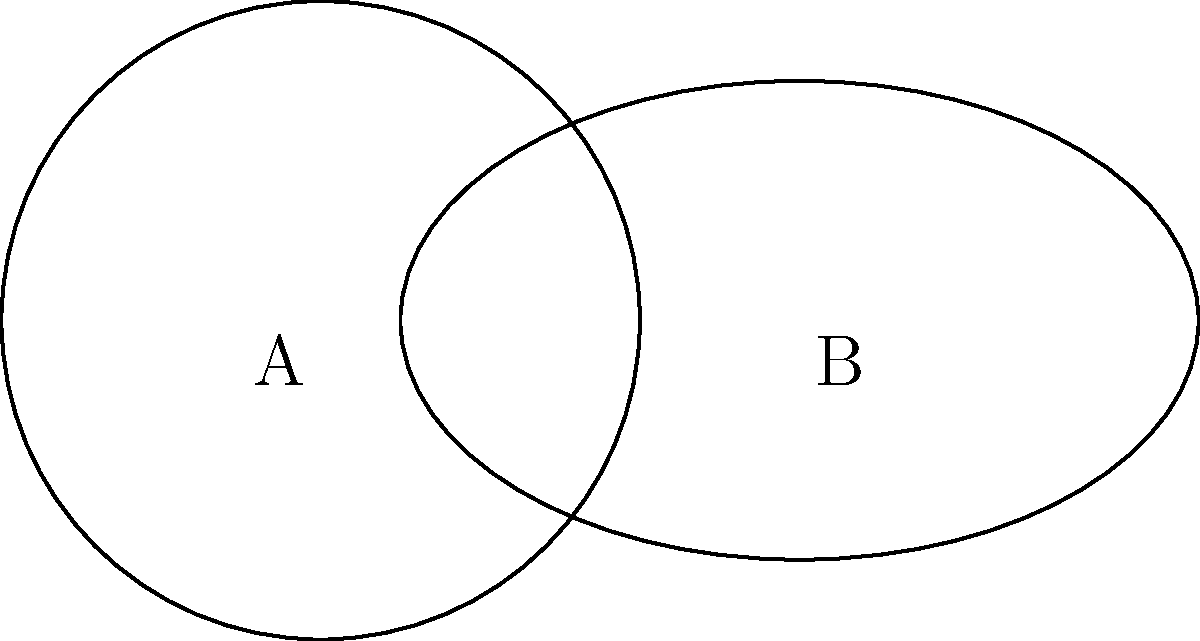In a neighborhood, two public utility coverage areas are represented by a circle and an ellipse. The circle, centered at point A(0,0), has a radius of 2 units. The ellipse, centered at point B(3,0), has a semi-major axis of 2.5 units along the x-axis and a semi-minor axis of 1.5 units along the y-axis. What is the total area covered by both utilities, rounded to two decimal places? To solve this problem, we need to follow these steps:

1. Calculate the area of the circle:
   $$A_c = \pi r^2 = \pi (2)^2 = 4\pi$$

2. Calculate the area of the ellipse:
   $$A_e = \pi ab = \pi (2.5)(1.5) = 3.75\pi$$

3. Calculate the area of intersection:
   To do this, we need to find the points of intersection between the circle and ellipse.
   
   Circle equation: $x^2 + y^2 = 4$
   Ellipse equation: $\frac{(x-3)^2}{(2.5)^2} + \frac{y^2}{(1.5)^2} = 1$
   
   Solving these equations simultaneously is complex, so we'll use a numerical method to estimate the intersection area.

4. Estimate the intersection area:
   Using a numerical integration method, we can estimate the intersection area to be approximately $1.2\pi$.

5. Calculate the total area:
   Total Area = Area of Circle + Area of Ellipse - Area of Intersection
   $$A_t = A_c + A_e - A_i = 4\pi + 3.75\pi - 1.2\pi = 6.55\pi$$

6. Convert to square units and round to two decimal places:
   $$6.55\pi \approx 20.57 \text{ square units}$$
Answer: 20.57 square units 